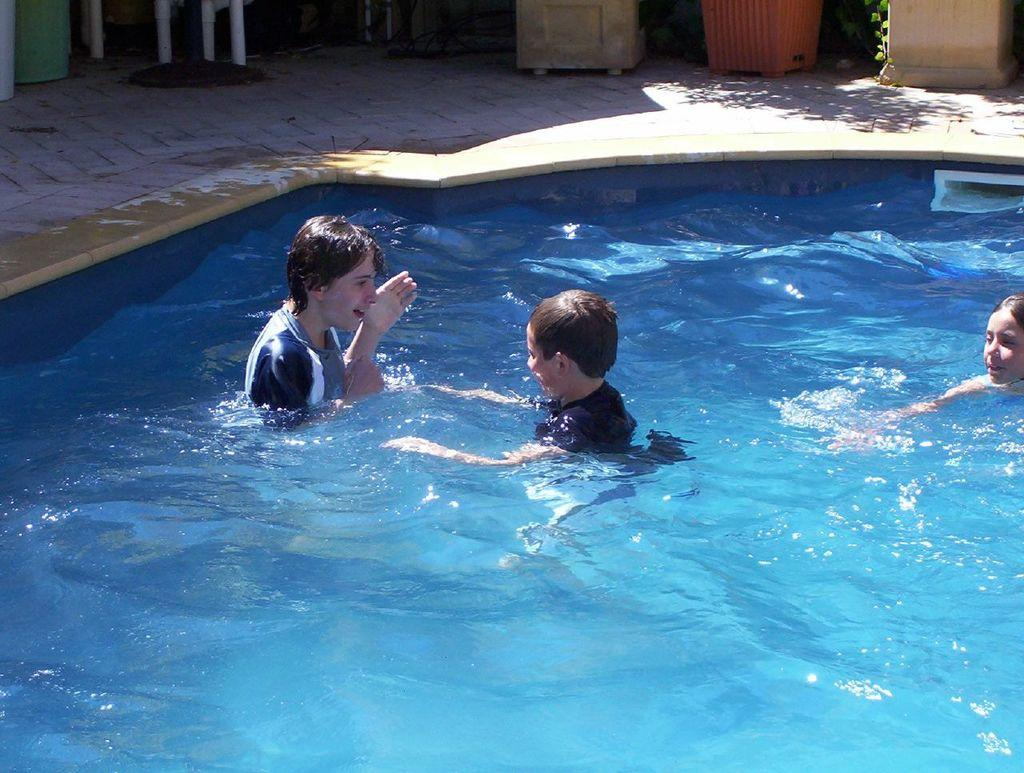What are the kids doing in the image? The kids are in the swimming pool in the foreground of the image. What can be seen in the background of the image? There are pots in the background of the image. What type of church can be seen in the image? There is no church present in the image; it features kids in a swimming pool and pots in the background. What is the wound on the tongue of the person in the image? There is no person with a wound on their tongue in the image. 